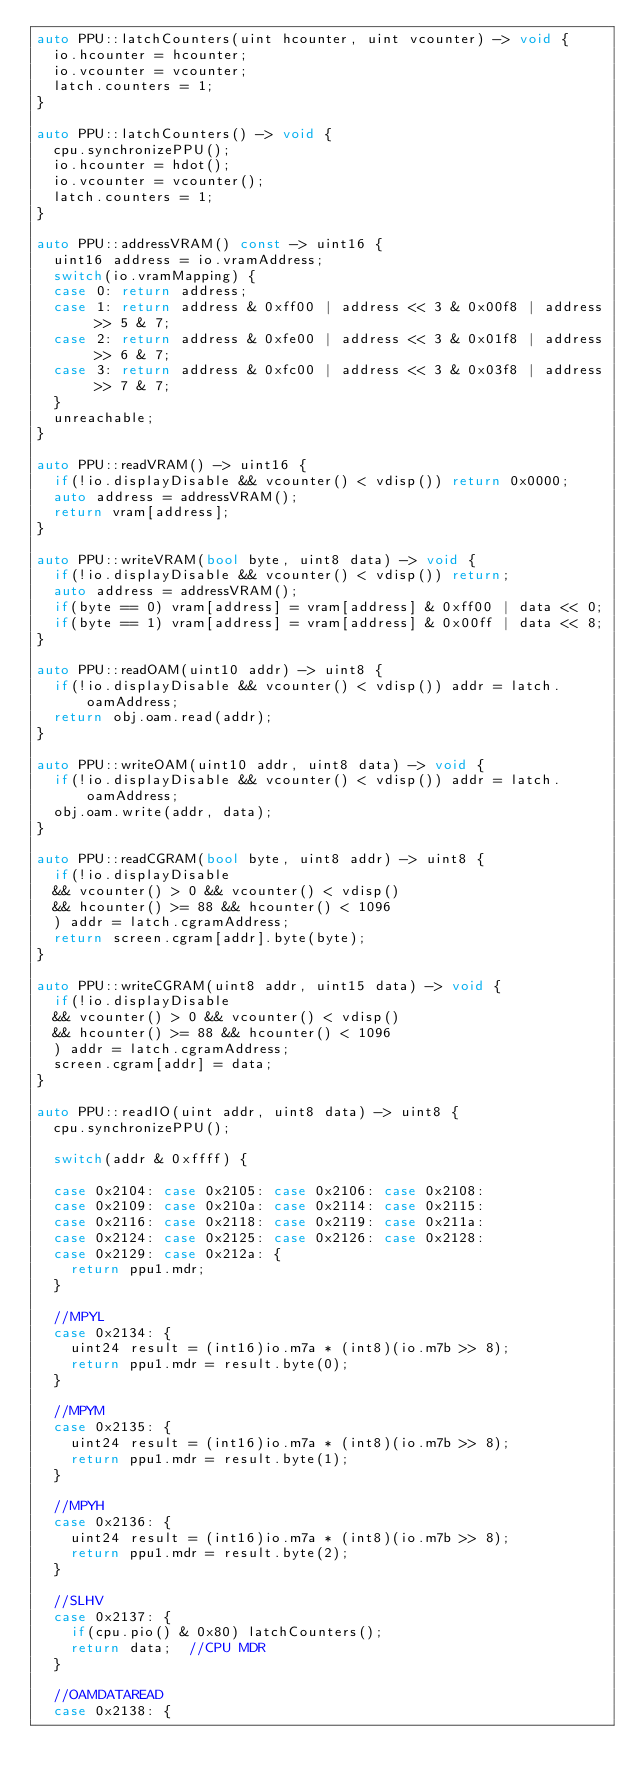Convert code to text. <code><loc_0><loc_0><loc_500><loc_500><_C++_>auto PPU::latchCounters(uint hcounter, uint vcounter) -> void {
  io.hcounter = hcounter;
  io.vcounter = vcounter;
  latch.counters = 1;
}

auto PPU::latchCounters() -> void {
  cpu.synchronizePPU();
  io.hcounter = hdot();
  io.vcounter = vcounter();
  latch.counters = 1;
}

auto PPU::addressVRAM() const -> uint16 {
  uint16 address = io.vramAddress;
  switch(io.vramMapping) {
  case 0: return address;
  case 1: return address & 0xff00 | address << 3 & 0x00f8 | address >> 5 & 7;
  case 2: return address & 0xfe00 | address << 3 & 0x01f8 | address >> 6 & 7;
  case 3: return address & 0xfc00 | address << 3 & 0x03f8 | address >> 7 & 7;
  }
  unreachable;
}

auto PPU::readVRAM() -> uint16 {
  if(!io.displayDisable && vcounter() < vdisp()) return 0x0000;
  auto address = addressVRAM();
  return vram[address];
}

auto PPU::writeVRAM(bool byte, uint8 data) -> void {
  if(!io.displayDisable && vcounter() < vdisp()) return;
  auto address = addressVRAM();
  if(byte == 0) vram[address] = vram[address] & 0xff00 | data << 0;
  if(byte == 1) vram[address] = vram[address] & 0x00ff | data << 8;
}

auto PPU::readOAM(uint10 addr) -> uint8 {
  if(!io.displayDisable && vcounter() < vdisp()) addr = latch.oamAddress;
  return obj.oam.read(addr);
}

auto PPU::writeOAM(uint10 addr, uint8 data) -> void {
  if(!io.displayDisable && vcounter() < vdisp()) addr = latch.oamAddress;
  obj.oam.write(addr, data);
}

auto PPU::readCGRAM(bool byte, uint8 addr) -> uint8 {
  if(!io.displayDisable
  && vcounter() > 0 && vcounter() < vdisp()
  && hcounter() >= 88 && hcounter() < 1096
  ) addr = latch.cgramAddress;
  return screen.cgram[addr].byte(byte);
}

auto PPU::writeCGRAM(uint8 addr, uint15 data) -> void {
  if(!io.displayDisable
  && vcounter() > 0 && vcounter() < vdisp()
  && hcounter() >= 88 && hcounter() < 1096
  ) addr = latch.cgramAddress;
  screen.cgram[addr] = data;
}

auto PPU::readIO(uint addr, uint8 data) -> uint8 {
  cpu.synchronizePPU();

  switch(addr & 0xffff) {

  case 0x2104: case 0x2105: case 0x2106: case 0x2108:
  case 0x2109: case 0x210a: case 0x2114: case 0x2115:
  case 0x2116: case 0x2118: case 0x2119: case 0x211a:
  case 0x2124: case 0x2125: case 0x2126: case 0x2128:
  case 0x2129: case 0x212a: {
    return ppu1.mdr;
  }

  //MPYL
  case 0x2134: {
    uint24 result = (int16)io.m7a * (int8)(io.m7b >> 8);
    return ppu1.mdr = result.byte(0);
  }

  //MPYM
  case 0x2135: {
    uint24 result = (int16)io.m7a * (int8)(io.m7b >> 8);
    return ppu1.mdr = result.byte(1);
  }

  //MPYH
  case 0x2136: {
    uint24 result = (int16)io.m7a * (int8)(io.m7b >> 8);
    return ppu1.mdr = result.byte(2);
  }

  //SLHV
  case 0x2137: {
    if(cpu.pio() & 0x80) latchCounters();
    return data;  //CPU MDR
  }

  //OAMDATAREAD
  case 0x2138: {</code> 